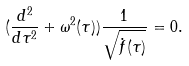Convert formula to latex. <formula><loc_0><loc_0><loc_500><loc_500>( \frac { d ^ { 2 } } { d \tau ^ { 2 } } + \omega ^ { 2 } ( \tau ) ) \frac { 1 } { \sqrt { \dot { f } ( \tau ) } } = 0 .</formula> 